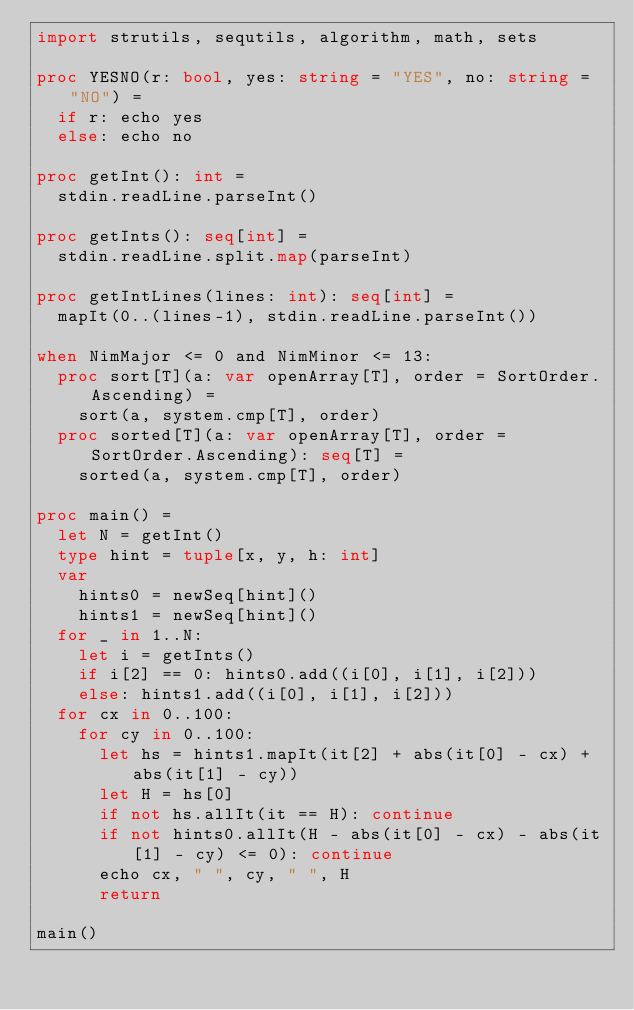Convert code to text. <code><loc_0><loc_0><loc_500><loc_500><_Nim_>import strutils, sequtils, algorithm, math, sets

proc YESNO(r: bool, yes: string = "YES", no: string = "NO") =
  if r: echo yes
  else: echo no

proc getInt(): int =
  stdin.readLine.parseInt()

proc getInts(): seq[int] =
  stdin.readLine.split.map(parseInt)

proc getIntLines(lines: int): seq[int] =
  mapIt(0..(lines-1), stdin.readLine.parseInt())

when NimMajor <= 0 and NimMinor <= 13:
  proc sort[T](a: var openArray[T], order = SortOrder.Ascending) =
    sort(a, system.cmp[T], order)
  proc sorted[T](a: var openArray[T], order = SortOrder.Ascending): seq[T] =
    sorted(a, system.cmp[T], order)

proc main() =
  let N = getInt()
  type hint = tuple[x, y, h: int]
  var
    hints0 = newSeq[hint]()
    hints1 = newSeq[hint]()
  for _ in 1..N:
    let i = getInts()
    if i[2] == 0: hints0.add((i[0], i[1], i[2]))
    else: hints1.add((i[0], i[1], i[2]))
  for cx in 0..100:
    for cy in 0..100:
      let hs = hints1.mapIt(it[2] + abs(it[0] - cx) + abs(it[1] - cy))
      let H = hs[0]
      if not hs.allIt(it == H): continue
      if not hints0.allIt(H - abs(it[0] - cx) - abs(it[1] - cy) <= 0): continue
      echo cx, " ", cy, " ", H
      return

main()</code> 